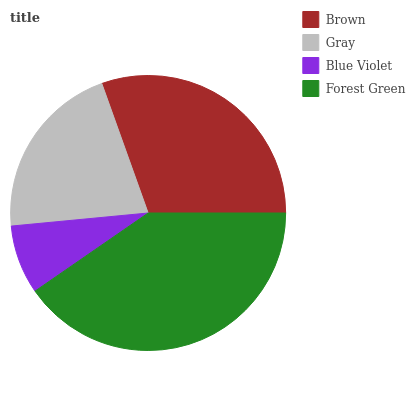Is Blue Violet the minimum?
Answer yes or no. Yes. Is Forest Green the maximum?
Answer yes or no. Yes. Is Gray the minimum?
Answer yes or no. No. Is Gray the maximum?
Answer yes or no. No. Is Brown greater than Gray?
Answer yes or no. Yes. Is Gray less than Brown?
Answer yes or no. Yes. Is Gray greater than Brown?
Answer yes or no. No. Is Brown less than Gray?
Answer yes or no. No. Is Brown the high median?
Answer yes or no. Yes. Is Gray the low median?
Answer yes or no. Yes. Is Blue Violet the high median?
Answer yes or no. No. Is Brown the low median?
Answer yes or no. No. 